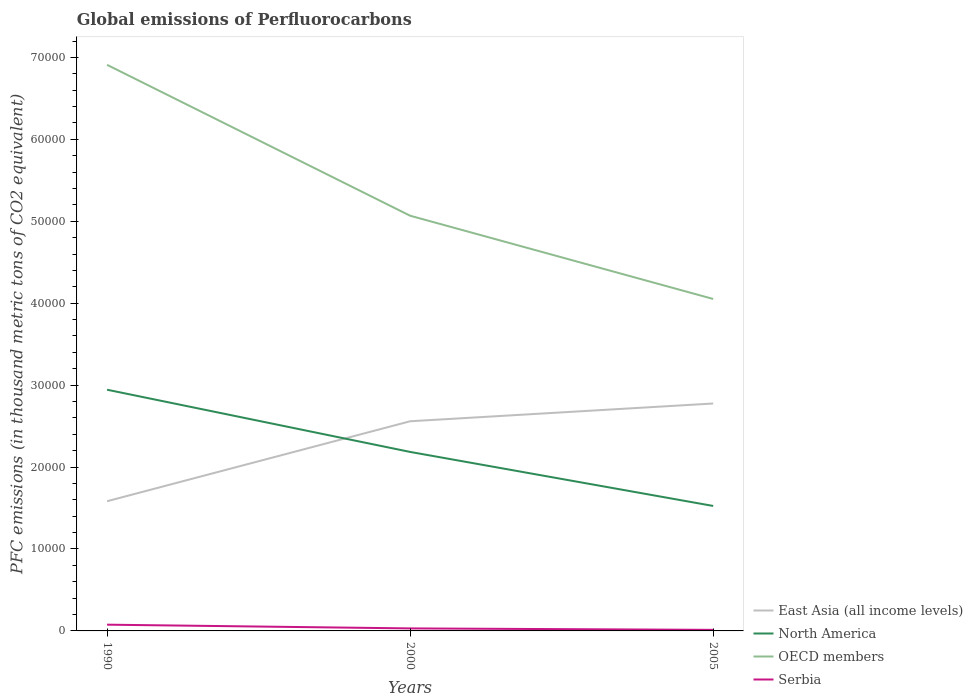How many different coloured lines are there?
Your answer should be very brief. 4. Is the number of lines equal to the number of legend labels?
Provide a succinct answer. Yes. Across all years, what is the maximum global emissions of Perfluorocarbons in North America?
Offer a very short reply. 1.53e+04. In which year was the global emissions of Perfluorocarbons in Serbia maximum?
Your answer should be compact. 2005. What is the total global emissions of Perfluorocarbons in Serbia in the graph?
Ensure brevity in your answer.  455.8. What is the difference between the highest and the second highest global emissions of Perfluorocarbons in OECD members?
Keep it short and to the point. 2.86e+04. Is the global emissions of Perfluorocarbons in OECD members strictly greater than the global emissions of Perfluorocarbons in East Asia (all income levels) over the years?
Your answer should be very brief. No. How many lines are there?
Your answer should be very brief. 4. Are the values on the major ticks of Y-axis written in scientific E-notation?
Make the answer very short. No. Does the graph contain any zero values?
Your answer should be compact. No. Does the graph contain grids?
Make the answer very short. No. Where does the legend appear in the graph?
Your answer should be compact. Bottom right. How are the legend labels stacked?
Offer a very short reply. Vertical. What is the title of the graph?
Your answer should be compact. Global emissions of Perfluorocarbons. Does "Liberia" appear as one of the legend labels in the graph?
Give a very brief answer. No. What is the label or title of the Y-axis?
Ensure brevity in your answer.  PFC emissions (in thousand metric tons of CO2 equivalent). What is the PFC emissions (in thousand metric tons of CO2 equivalent) in East Asia (all income levels) in 1990?
Ensure brevity in your answer.  1.58e+04. What is the PFC emissions (in thousand metric tons of CO2 equivalent) of North America in 1990?
Provide a short and direct response. 2.94e+04. What is the PFC emissions (in thousand metric tons of CO2 equivalent) of OECD members in 1990?
Your response must be concise. 6.91e+04. What is the PFC emissions (in thousand metric tons of CO2 equivalent) of Serbia in 1990?
Your answer should be compact. 761.9. What is the PFC emissions (in thousand metric tons of CO2 equivalent) of East Asia (all income levels) in 2000?
Your answer should be compact. 2.56e+04. What is the PFC emissions (in thousand metric tons of CO2 equivalent) of North America in 2000?
Offer a very short reply. 2.18e+04. What is the PFC emissions (in thousand metric tons of CO2 equivalent) of OECD members in 2000?
Provide a succinct answer. 5.07e+04. What is the PFC emissions (in thousand metric tons of CO2 equivalent) of Serbia in 2000?
Make the answer very short. 306.1. What is the PFC emissions (in thousand metric tons of CO2 equivalent) of East Asia (all income levels) in 2005?
Your response must be concise. 2.78e+04. What is the PFC emissions (in thousand metric tons of CO2 equivalent) in North America in 2005?
Offer a terse response. 1.53e+04. What is the PFC emissions (in thousand metric tons of CO2 equivalent) in OECD members in 2005?
Give a very brief answer. 4.05e+04. What is the PFC emissions (in thousand metric tons of CO2 equivalent) in Serbia in 2005?
Provide a succinct answer. 129. Across all years, what is the maximum PFC emissions (in thousand metric tons of CO2 equivalent) of East Asia (all income levels)?
Give a very brief answer. 2.78e+04. Across all years, what is the maximum PFC emissions (in thousand metric tons of CO2 equivalent) of North America?
Keep it short and to the point. 2.94e+04. Across all years, what is the maximum PFC emissions (in thousand metric tons of CO2 equivalent) in OECD members?
Your response must be concise. 6.91e+04. Across all years, what is the maximum PFC emissions (in thousand metric tons of CO2 equivalent) in Serbia?
Make the answer very short. 761.9. Across all years, what is the minimum PFC emissions (in thousand metric tons of CO2 equivalent) of East Asia (all income levels)?
Offer a very short reply. 1.58e+04. Across all years, what is the minimum PFC emissions (in thousand metric tons of CO2 equivalent) in North America?
Offer a terse response. 1.53e+04. Across all years, what is the minimum PFC emissions (in thousand metric tons of CO2 equivalent) in OECD members?
Provide a short and direct response. 4.05e+04. Across all years, what is the minimum PFC emissions (in thousand metric tons of CO2 equivalent) of Serbia?
Provide a short and direct response. 129. What is the total PFC emissions (in thousand metric tons of CO2 equivalent) in East Asia (all income levels) in the graph?
Keep it short and to the point. 6.92e+04. What is the total PFC emissions (in thousand metric tons of CO2 equivalent) in North America in the graph?
Give a very brief answer. 6.65e+04. What is the total PFC emissions (in thousand metric tons of CO2 equivalent) in OECD members in the graph?
Give a very brief answer. 1.60e+05. What is the total PFC emissions (in thousand metric tons of CO2 equivalent) in Serbia in the graph?
Keep it short and to the point. 1197. What is the difference between the PFC emissions (in thousand metric tons of CO2 equivalent) of East Asia (all income levels) in 1990 and that in 2000?
Provide a succinct answer. -9759.3. What is the difference between the PFC emissions (in thousand metric tons of CO2 equivalent) of North America in 1990 and that in 2000?
Your response must be concise. 7592.7. What is the difference between the PFC emissions (in thousand metric tons of CO2 equivalent) of OECD members in 1990 and that in 2000?
Your answer should be compact. 1.84e+04. What is the difference between the PFC emissions (in thousand metric tons of CO2 equivalent) in Serbia in 1990 and that in 2000?
Make the answer very short. 455.8. What is the difference between the PFC emissions (in thousand metric tons of CO2 equivalent) in East Asia (all income levels) in 1990 and that in 2005?
Provide a succinct answer. -1.19e+04. What is the difference between the PFC emissions (in thousand metric tons of CO2 equivalent) of North America in 1990 and that in 2005?
Ensure brevity in your answer.  1.42e+04. What is the difference between the PFC emissions (in thousand metric tons of CO2 equivalent) of OECD members in 1990 and that in 2005?
Ensure brevity in your answer.  2.86e+04. What is the difference between the PFC emissions (in thousand metric tons of CO2 equivalent) in Serbia in 1990 and that in 2005?
Make the answer very short. 632.9. What is the difference between the PFC emissions (in thousand metric tons of CO2 equivalent) of East Asia (all income levels) in 2000 and that in 2005?
Your answer should be compact. -2167.69. What is the difference between the PFC emissions (in thousand metric tons of CO2 equivalent) of North America in 2000 and that in 2005?
Keep it short and to the point. 6595.81. What is the difference between the PFC emissions (in thousand metric tons of CO2 equivalent) of OECD members in 2000 and that in 2005?
Provide a short and direct response. 1.02e+04. What is the difference between the PFC emissions (in thousand metric tons of CO2 equivalent) in Serbia in 2000 and that in 2005?
Your response must be concise. 177.1. What is the difference between the PFC emissions (in thousand metric tons of CO2 equivalent) of East Asia (all income levels) in 1990 and the PFC emissions (in thousand metric tons of CO2 equivalent) of North America in 2000?
Make the answer very short. -6017.2. What is the difference between the PFC emissions (in thousand metric tons of CO2 equivalent) of East Asia (all income levels) in 1990 and the PFC emissions (in thousand metric tons of CO2 equivalent) of OECD members in 2000?
Your response must be concise. -3.48e+04. What is the difference between the PFC emissions (in thousand metric tons of CO2 equivalent) in East Asia (all income levels) in 1990 and the PFC emissions (in thousand metric tons of CO2 equivalent) in Serbia in 2000?
Your answer should be compact. 1.55e+04. What is the difference between the PFC emissions (in thousand metric tons of CO2 equivalent) in North America in 1990 and the PFC emissions (in thousand metric tons of CO2 equivalent) in OECD members in 2000?
Your response must be concise. -2.12e+04. What is the difference between the PFC emissions (in thousand metric tons of CO2 equivalent) in North America in 1990 and the PFC emissions (in thousand metric tons of CO2 equivalent) in Serbia in 2000?
Provide a succinct answer. 2.91e+04. What is the difference between the PFC emissions (in thousand metric tons of CO2 equivalent) of OECD members in 1990 and the PFC emissions (in thousand metric tons of CO2 equivalent) of Serbia in 2000?
Make the answer very short. 6.88e+04. What is the difference between the PFC emissions (in thousand metric tons of CO2 equivalent) of East Asia (all income levels) in 1990 and the PFC emissions (in thousand metric tons of CO2 equivalent) of North America in 2005?
Ensure brevity in your answer.  578.61. What is the difference between the PFC emissions (in thousand metric tons of CO2 equivalent) in East Asia (all income levels) in 1990 and the PFC emissions (in thousand metric tons of CO2 equivalent) in OECD members in 2005?
Your answer should be very brief. -2.47e+04. What is the difference between the PFC emissions (in thousand metric tons of CO2 equivalent) in East Asia (all income levels) in 1990 and the PFC emissions (in thousand metric tons of CO2 equivalent) in Serbia in 2005?
Offer a very short reply. 1.57e+04. What is the difference between the PFC emissions (in thousand metric tons of CO2 equivalent) in North America in 1990 and the PFC emissions (in thousand metric tons of CO2 equivalent) in OECD members in 2005?
Your answer should be very brief. -1.11e+04. What is the difference between the PFC emissions (in thousand metric tons of CO2 equivalent) of North America in 1990 and the PFC emissions (in thousand metric tons of CO2 equivalent) of Serbia in 2005?
Keep it short and to the point. 2.93e+04. What is the difference between the PFC emissions (in thousand metric tons of CO2 equivalent) in OECD members in 1990 and the PFC emissions (in thousand metric tons of CO2 equivalent) in Serbia in 2005?
Your answer should be very brief. 6.90e+04. What is the difference between the PFC emissions (in thousand metric tons of CO2 equivalent) of East Asia (all income levels) in 2000 and the PFC emissions (in thousand metric tons of CO2 equivalent) of North America in 2005?
Ensure brevity in your answer.  1.03e+04. What is the difference between the PFC emissions (in thousand metric tons of CO2 equivalent) of East Asia (all income levels) in 2000 and the PFC emissions (in thousand metric tons of CO2 equivalent) of OECD members in 2005?
Ensure brevity in your answer.  -1.49e+04. What is the difference between the PFC emissions (in thousand metric tons of CO2 equivalent) of East Asia (all income levels) in 2000 and the PFC emissions (in thousand metric tons of CO2 equivalent) of Serbia in 2005?
Offer a terse response. 2.55e+04. What is the difference between the PFC emissions (in thousand metric tons of CO2 equivalent) of North America in 2000 and the PFC emissions (in thousand metric tons of CO2 equivalent) of OECD members in 2005?
Provide a short and direct response. -1.87e+04. What is the difference between the PFC emissions (in thousand metric tons of CO2 equivalent) of North America in 2000 and the PFC emissions (in thousand metric tons of CO2 equivalent) of Serbia in 2005?
Offer a very short reply. 2.17e+04. What is the difference between the PFC emissions (in thousand metric tons of CO2 equivalent) of OECD members in 2000 and the PFC emissions (in thousand metric tons of CO2 equivalent) of Serbia in 2005?
Offer a terse response. 5.06e+04. What is the average PFC emissions (in thousand metric tons of CO2 equivalent) of East Asia (all income levels) per year?
Provide a succinct answer. 2.31e+04. What is the average PFC emissions (in thousand metric tons of CO2 equivalent) of North America per year?
Ensure brevity in your answer.  2.22e+04. What is the average PFC emissions (in thousand metric tons of CO2 equivalent) of OECD members per year?
Your answer should be compact. 5.34e+04. What is the average PFC emissions (in thousand metric tons of CO2 equivalent) in Serbia per year?
Provide a short and direct response. 399. In the year 1990, what is the difference between the PFC emissions (in thousand metric tons of CO2 equivalent) of East Asia (all income levels) and PFC emissions (in thousand metric tons of CO2 equivalent) of North America?
Provide a succinct answer. -1.36e+04. In the year 1990, what is the difference between the PFC emissions (in thousand metric tons of CO2 equivalent) in East Asia (all income levels) and PFC emissions (in thousand metric tons of CO2 equivalent) in OECD members?
Make the answer very short. -5.33e+04. In the year 1990, what is the difference between the PFC emissions (in thousand metric tons of CO2 equivalent) of East Asia (all income levels) and PFC emissions (in thousand metric tons of CO2 equivalent) of Serbia?
Offer a terse response. 1.51e+04. In the year 1990, what is the difference between the PFC emissions (in thousand metric tons of CO2 equivalent) in North America and PFC emissions (in thousand metric tons of CO2 equivalent) in OECD members?
Ensure brevity in your answer.  -3.97e+04. In the year 1990, what is the difference between the PFC emissions (in thousand metric tons of CO2 equivalent) in North America and PFC emissions (in thousand metric tons of CO2 equivalent) in Serbia?
Offer a terse response. 2.87e+04. In the year 1990, what is the difference between the PFC emissions (in thousand metric tons of CO2 equivalent) in OECD members and PFC emissions (in thousand metric tons of CO2 equivalent) in Serbia?
Provide a short and direct response. 6.83e+04. In the year 2000, what is the difference between the PFC emissions (in thousand metric tons of CO2 equivalent) of East Asia (all income levels) and PFC emissions (in thousand metric tons of CO2 equivalent) of North America?
Keep it short and to the point. 3742.1. In the year 2000, what is the difference between the PFC emissions (in thousand metric tons of CO2 equivalent) in East Asia (all income levels) and PFC emissions (in thousand metric tons of CO2 equivalent) in OECD members?
Offer a terse response. -2.51e+04. In the year 2000, what is the difference between the PFC emissions (in thousand metric tons of CO2 equivalent) in East Asia (all income levels) and PFC emissions (in thousand metric tons of CO2 equivalent) in Serbia?
Offer a terse response. 2.53e+04. In the year 2000, what is the difference between the PFC emissions (in thousand metric tons of CO2 equivalent) in North America and PFC emissions (in thousand metric tons of CO2 equivalent) in OECD members?
Ensure brevity in your answer.  -2.88e+04. In the year 2000, what is the difference between the PFC emissions (in thousand metric tons of CO2 equivalent) in North America and PFC emissions (in thousand metric tons of CO2 equivalent) in Serbia?
Give a very brief answer. 2.15e+04. In the year 2000, what is the difference between the PFC emissions (in thousand metric tons of CO2 equivalent) in OECD members and PFC emissions (in thousand metric tons of CO2 equivalent) in Serbia?
Give a very brief answer. 5.04e+04. In the year 2005, what is the difference between the PFC emissions (in thousand metric tons of CO2 equivalent) in East Asia (all income levels) and PFC emissions (in thousand metric tons of CO2 equivalent) in North America?
Provide a succinct answer. 1.25e+04. In the year 2005, what is the difference between the PFC emissions (in thousand metric tons of CO2 equivalent) of East Asia (all income levels) and PFC emissions (in thousand metric tons of CO2 equivalent) of OECD members?
Keep it short and to the point. -1.28e+04. In the year 2005, what is the difference between the PFC emissions (in thousand metric tons of CO2 equivalent) in East Asia (all income levels) and PFC emissions (in thousand metric tons of CO2 equivalent) in Serbia?
Keep it short and to the point. 2.76e+04. In the year 2005, what is the difference between the PFC emissions (in thousand metric tons of CO2 equivalent) in North America and PFC emissions (in thousand metric tons of CO2 equivalent) in OECD members?
Offer a very short reply. -2.53e+04. In the year 2005, what is the difference between the PFC emissions (in thousand metric tons of CO2 equivalent) in North America and PFC emissions (in thousand metric tons of CO2 equivalent) in Serbia?
Offer a very short reply. 1.51e+04. In the year 2005, what is the difference between the PFC emissions (in thousand metric tons of CO2 equivalent) in OECD members and PFC emissions (in thousand metric tons of CO2 equivalent) in Serbia?
Keep it short and to the point. 4.04e+04. What is the ratio of the PFC emissions (in thousand metric tons of CO2 equivalent) in East Asia (all income levels) in 1990 to that in 2000?
Provide a short and direct response. 0.62. What is the ratio of the PFC emissions (in thousand metric tons of CO2 equivalent) of North America in 1990 to that in 2000?
Make the answer very short. 1.35. What is the ratio of the PFC emissions (in thousand metric tons of CO2 equivalent) in OECD members in 1990 to that in 2000?
Your answer should be very brief. 1.36. What is the ratio of the PFC emissions (in thousand metric tons of CO2 equivalent) in Serbia in 1990 to that in 2000?
Your response must be concise. 2.49. What is the ratio of the PFC emissions (in thousand metric tons of CO2 equivalent) of East Asia (all income levels) in 1990 to that in 2005?
Give a very brief answer. 0.57. What is the ratio of the PFC emissions (in thousand metric tons of CO2 equivalent) of North America in 1990 to that in 2005?
Your answer should be compact. 1.93. What is the ratio of the PFC emissions (in thousand metric tons of CO2 equivalent) of OECD members in 1990 to that in 2005?
Your answer should be very brief. 1.71. What is the ratio of the PFC emissions (in thousand metric tons of CO2 equivalent) of Serbia in 1990 to that in 2005?
Make the answer very short. 5.91. What is the ratio of the PFC emissions (in thousand metric tons of CO2 equivalent) in East Asia (all income levels) in 2000 to that in 2005?
Provide a short and direct response. 0.92. What is the ratio of the PFC emissions (in thousand metric tons of CO2 equivalent) in North America in 2000 to that in 2005?
Your response must be concise. 1.43. What is the ratio of the PFC emissions (in thousand metric tons of CO2 equivalent) of OECD members in 2000 to that in 2005?
Give a very brief answer. 1.25. What is the ratio of the PFC emissions (in thousand metric tons of CO2 equivalent) in Serbia in 2000 to that in 2005?
Keep it short and to the point. 2.37. What is the difference between the highest and the second highest PFC emissions (in thousand metric tons of CO2 equivalent) in East Asia (all income levels)?
Your answer should be very brief. 2167.69. What is the difference between the highest and the second highest PFC emissions (in thousand metric tons of CO2 equivalent) in North America?
Offer a terse response. 7592.7. What is the difference between the highest and the second highest PFC emissions (in thousand metric tons of CO2 equivalent) in OECD members?
Make the answer very short. 1.84e+04. What is the difference between the highest and the second highest PFC emissions (in thousand metric tons of CO2 equivalent) in Serbia?
Your answer should be very brief. 455.8. What is the difference between the highest and the lowest PFC emissions (in thousand metric tons of CO2 equivalent) of East Asia (all income levels)?
Your answer should be compact. 1.19e+04. What is the difference between the highest and the lowest PFC emissions (in thousand metric tons of CO2 equivalent) of North America?
Make the answer very short. 1.42e+04. What is the difference between the highest and the lowest PFC emissions (in thousand metric tons of CO2 equivalent) in OECD members?
Give a very brief answer. 2.86e+04. What is the difference between the highest and the lowest PFC emissions (in thousand metric tons of CO2 equivalent) in Serbia?
Provide a short and direct response. 632.9. 